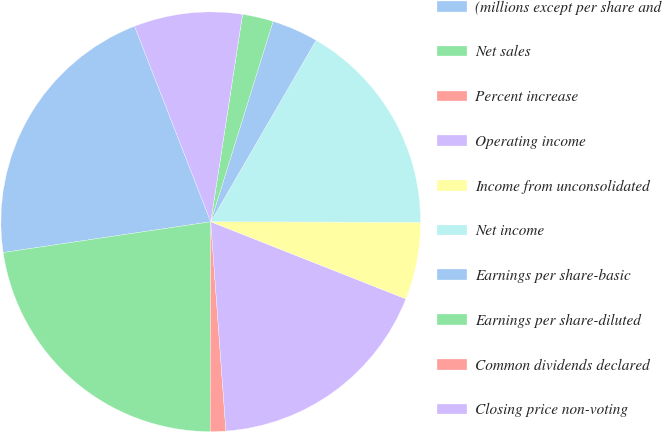Convert chart to OTSL. <chart><loc_0><loc_0><loc_500><loc_500><pie_chart><fcel>(millions except per share and<fcel>Net sales<fcel>Percent increase<fcel>Operating income<fcel>Income from unconsolidated<fcel>Net income<fcel>Earnings per share-basic<fcel>Earnings per share-diluted<fcel>Common dividends declared<fcel>Closing price non-voting<nl><fcel>21.42%<fcel>22.61%<fcel>1.19%<fcel>17.85%<fcel>5.95%<fcel>16.66%<fcel>3.57%<fcel>2.38%<fcel>0.0%<fcel>8.33%<nl></chart> 